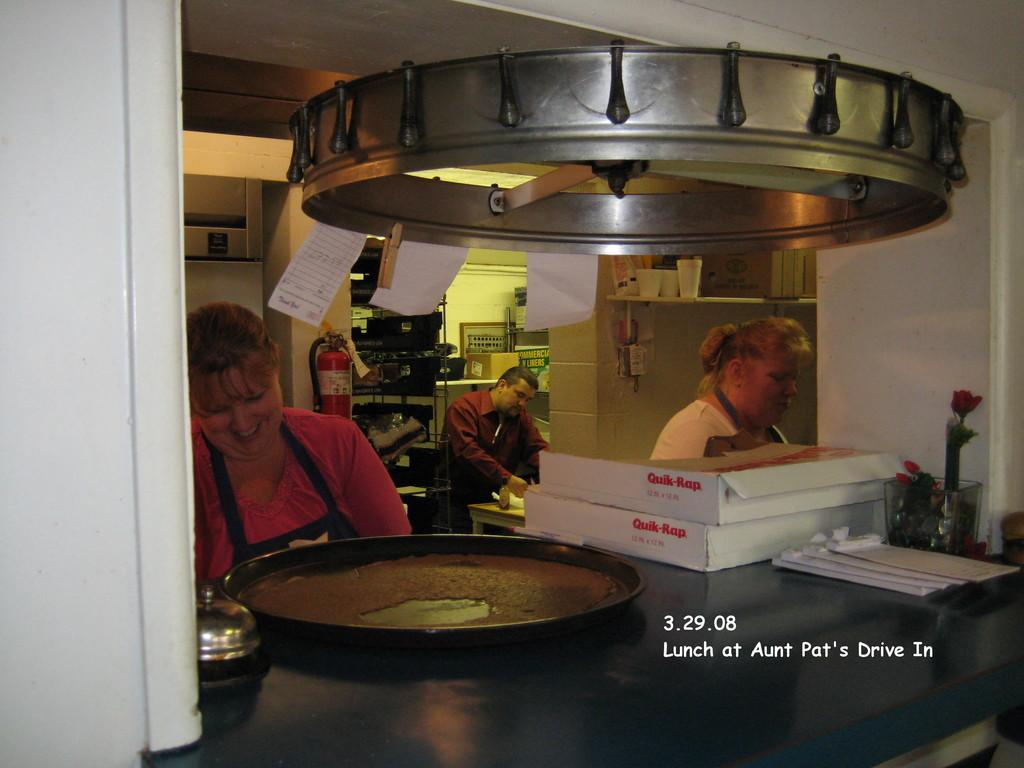<image>
Present a compact description of the photo's key features. Two ladies are working the lunch shift at Pat's Drive In. 